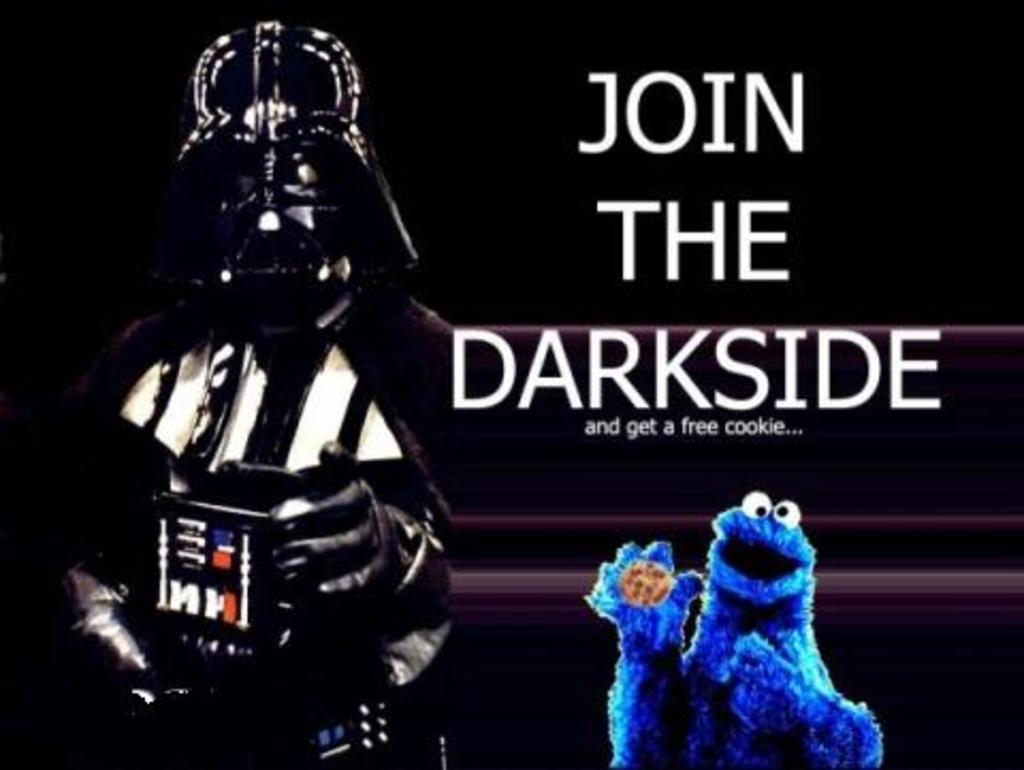Please provide a concise description of this image. This is an edited image. In this image we can see a person holding a device wearing a costume. We can also see some text and a doll holding a cookie. 